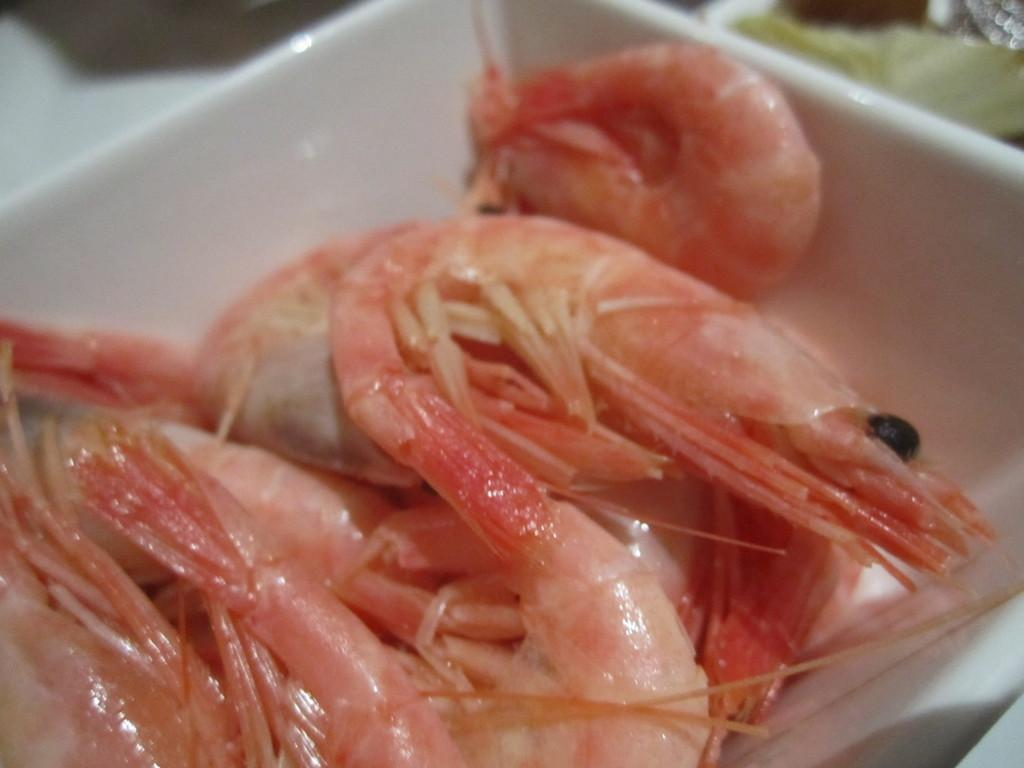What type of food is visible in the image? There are raw shrimps in the image. Where are the raw shrimps located? The raw shrimps are in a bowl. What is the color of the bowl? The bowl appears to be white in color. What language is the shoe speaking in the image? There is no shoe present in the image, and therefore no language can be attributed to it. 